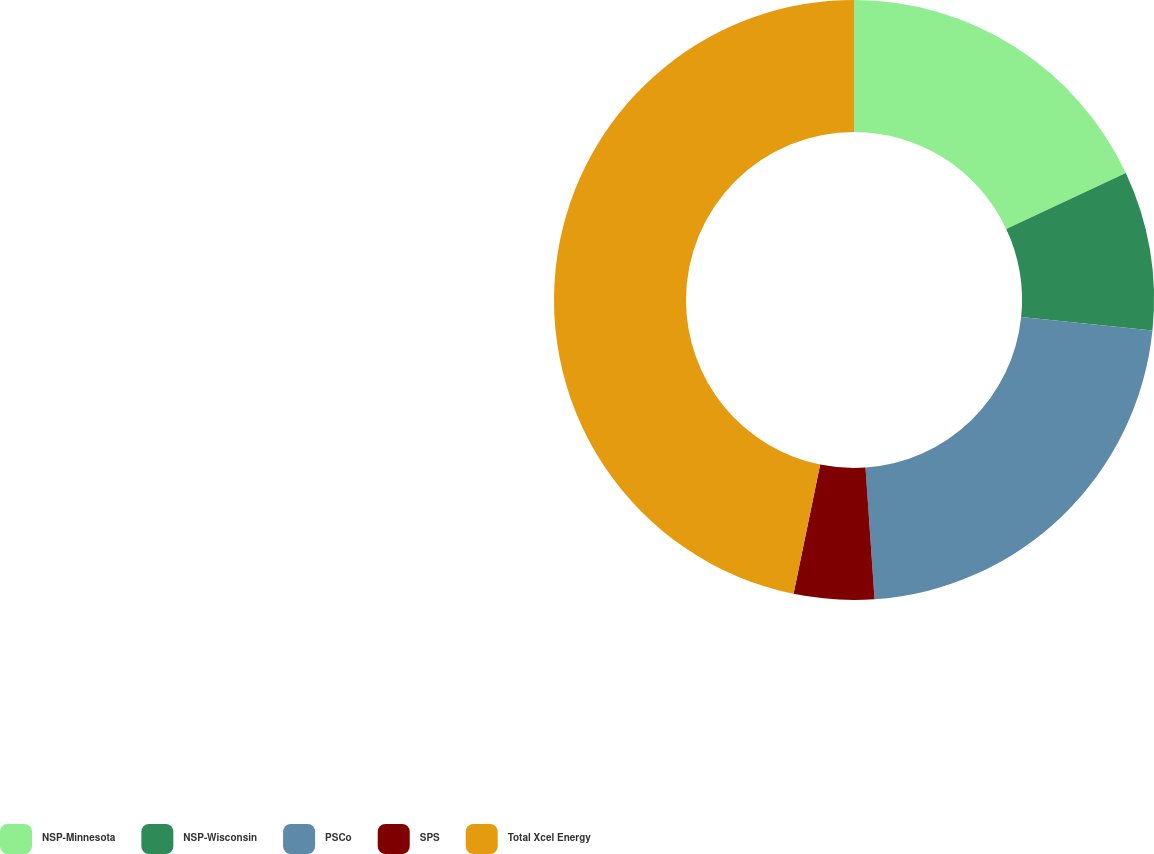<chart> <loc_0><loc_0><loc_500><loc_500><pie_chart><fcel>NSP-Minnesota<fcel>NSP-Wisconsin<fcel>PSCo<fcel>SPS<fcel>Total Xcel Energy<nl><fcel>18.05%<fcel>8.57%<fcel>22.29%<fcel>4.32%<fcel>46.77%<nl></chart> 